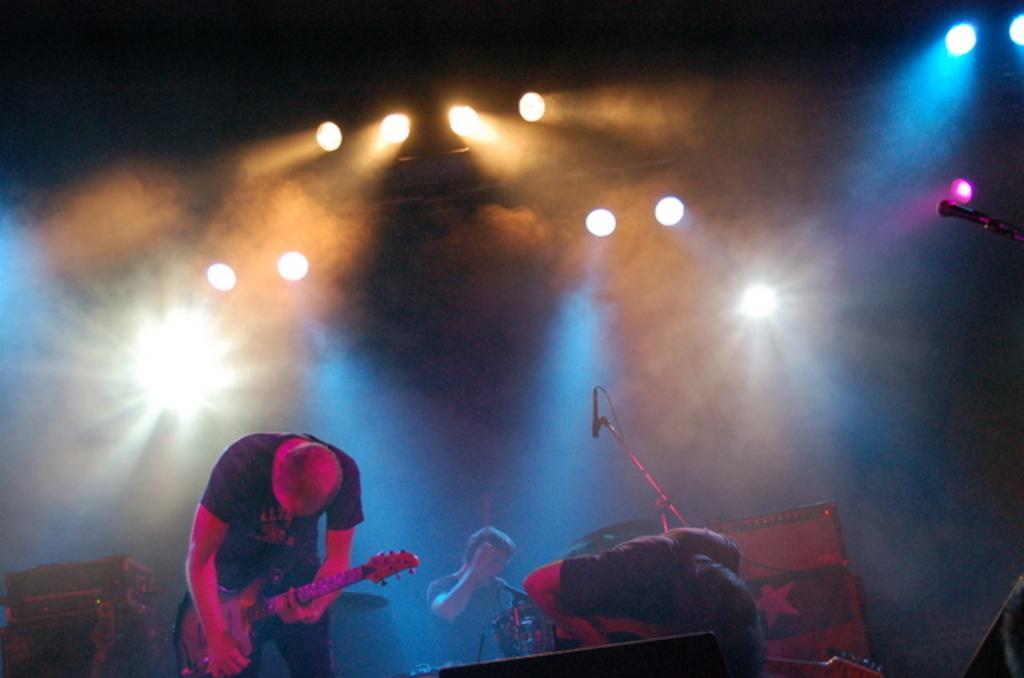Could you give a brief overview of what you see in this image? I can see two persons standing,One person is playing guitar. And this is the mike with the mike stand. At background I can see a person is playing drums. This looks like a stage show. These are the show lights. 